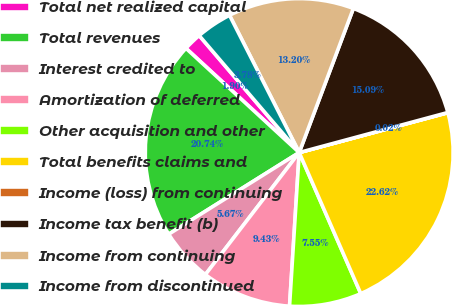Convert chart to OTSL. <chart><loc_0><loc_0><loc_500><loc_500><pie_chart><fcel>Total net realized capital<fcel>Total revenues<fcel>Interest credited to<fcel>Amortization of deferred<fcel>Other acquisition and other<fcel>Total benefits claims and<fcel>Income (loss) from continuing<fcel>Income tax benefit (b)<fcel>Income from continuing<fcel>Income from discontinued<nl><fcel>1.9%<fcel>20.74%<fcel>5.67%<fcel>9.43%<fcel>7.55%<fcel>22.62%<fcel>0.02%<fcel>15.09%<fcel>13.2%<fcel>3.78%<nl></chart> 